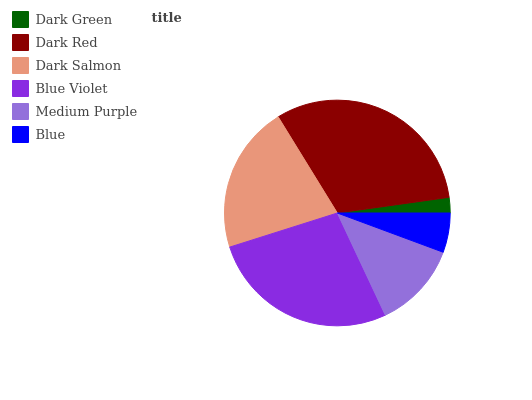Is Dark Green the minimum?
Answer yes or no. Yes. Is Dark Red the maximum?
Answer yes or no. Yes. Is Dark Salmon the minimum?
Answer yes or no. No. Is Dark Salmon the maximum?
Answer yes or no. No. Is Dark Red greater than Dark Salmon?
Answer yes or no. Yes. Is Dark Salmon less than Dark Red?
Answer yes or no. Yes. Is Dark Salmon greater than Dark Red?
Answer yes or no. No. Is Dark Red less than Dark Salmon?
Answer yes or no. No. Is Dark Salmon the high median?
Answer yes or no. Yes. Is Medium Purple the low median?
Answer yes or no. Yes. Is Dark Red the high median?
Answer yes or no. No. Is Dark Red the low median?
Answer yes or no. No. 